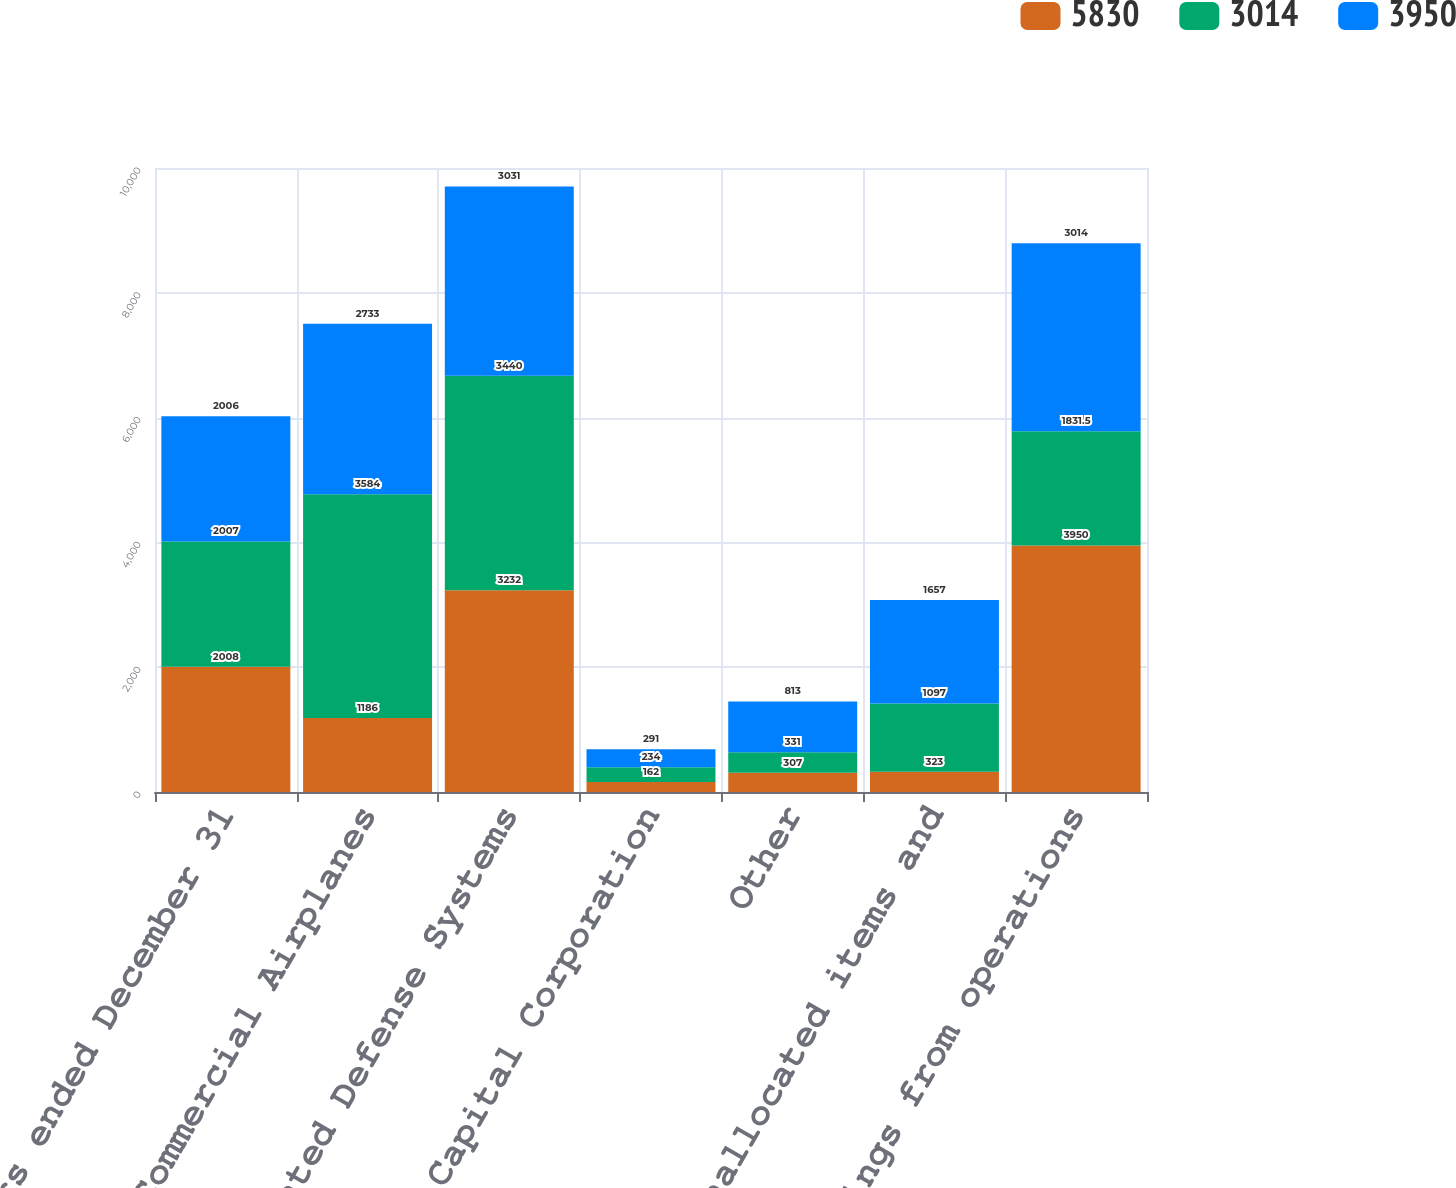Convert chart. <chart><loc_0><loc_0><loc_500><loc_500><stacked_bar_chart><ecel><fcel>Years ended December 31<fcel>Commercial Airplanes<fcel>Integrated Defense Systems<fcel>Boeing Capital Corporation<fcel>Other<fcel>Unallocated items and<fcel>Earnings from operations<nl><fcel>5830<fcel>2008<fcel>1186<fcel>3232<fcel>162<fcel>307<fcel>323<fcel>3950<nl><fcel>3014<fcel>2007<fcel>3584<fcel>3440<fcel>234<fcel>331<fcel>1097<fcel>1831.5<nl><fcel>3950<fcel>2006<fcel>2733<fcel>3031<fcel>291<fcel>813<fcel>1657<fcel>3014<nl></chart> 